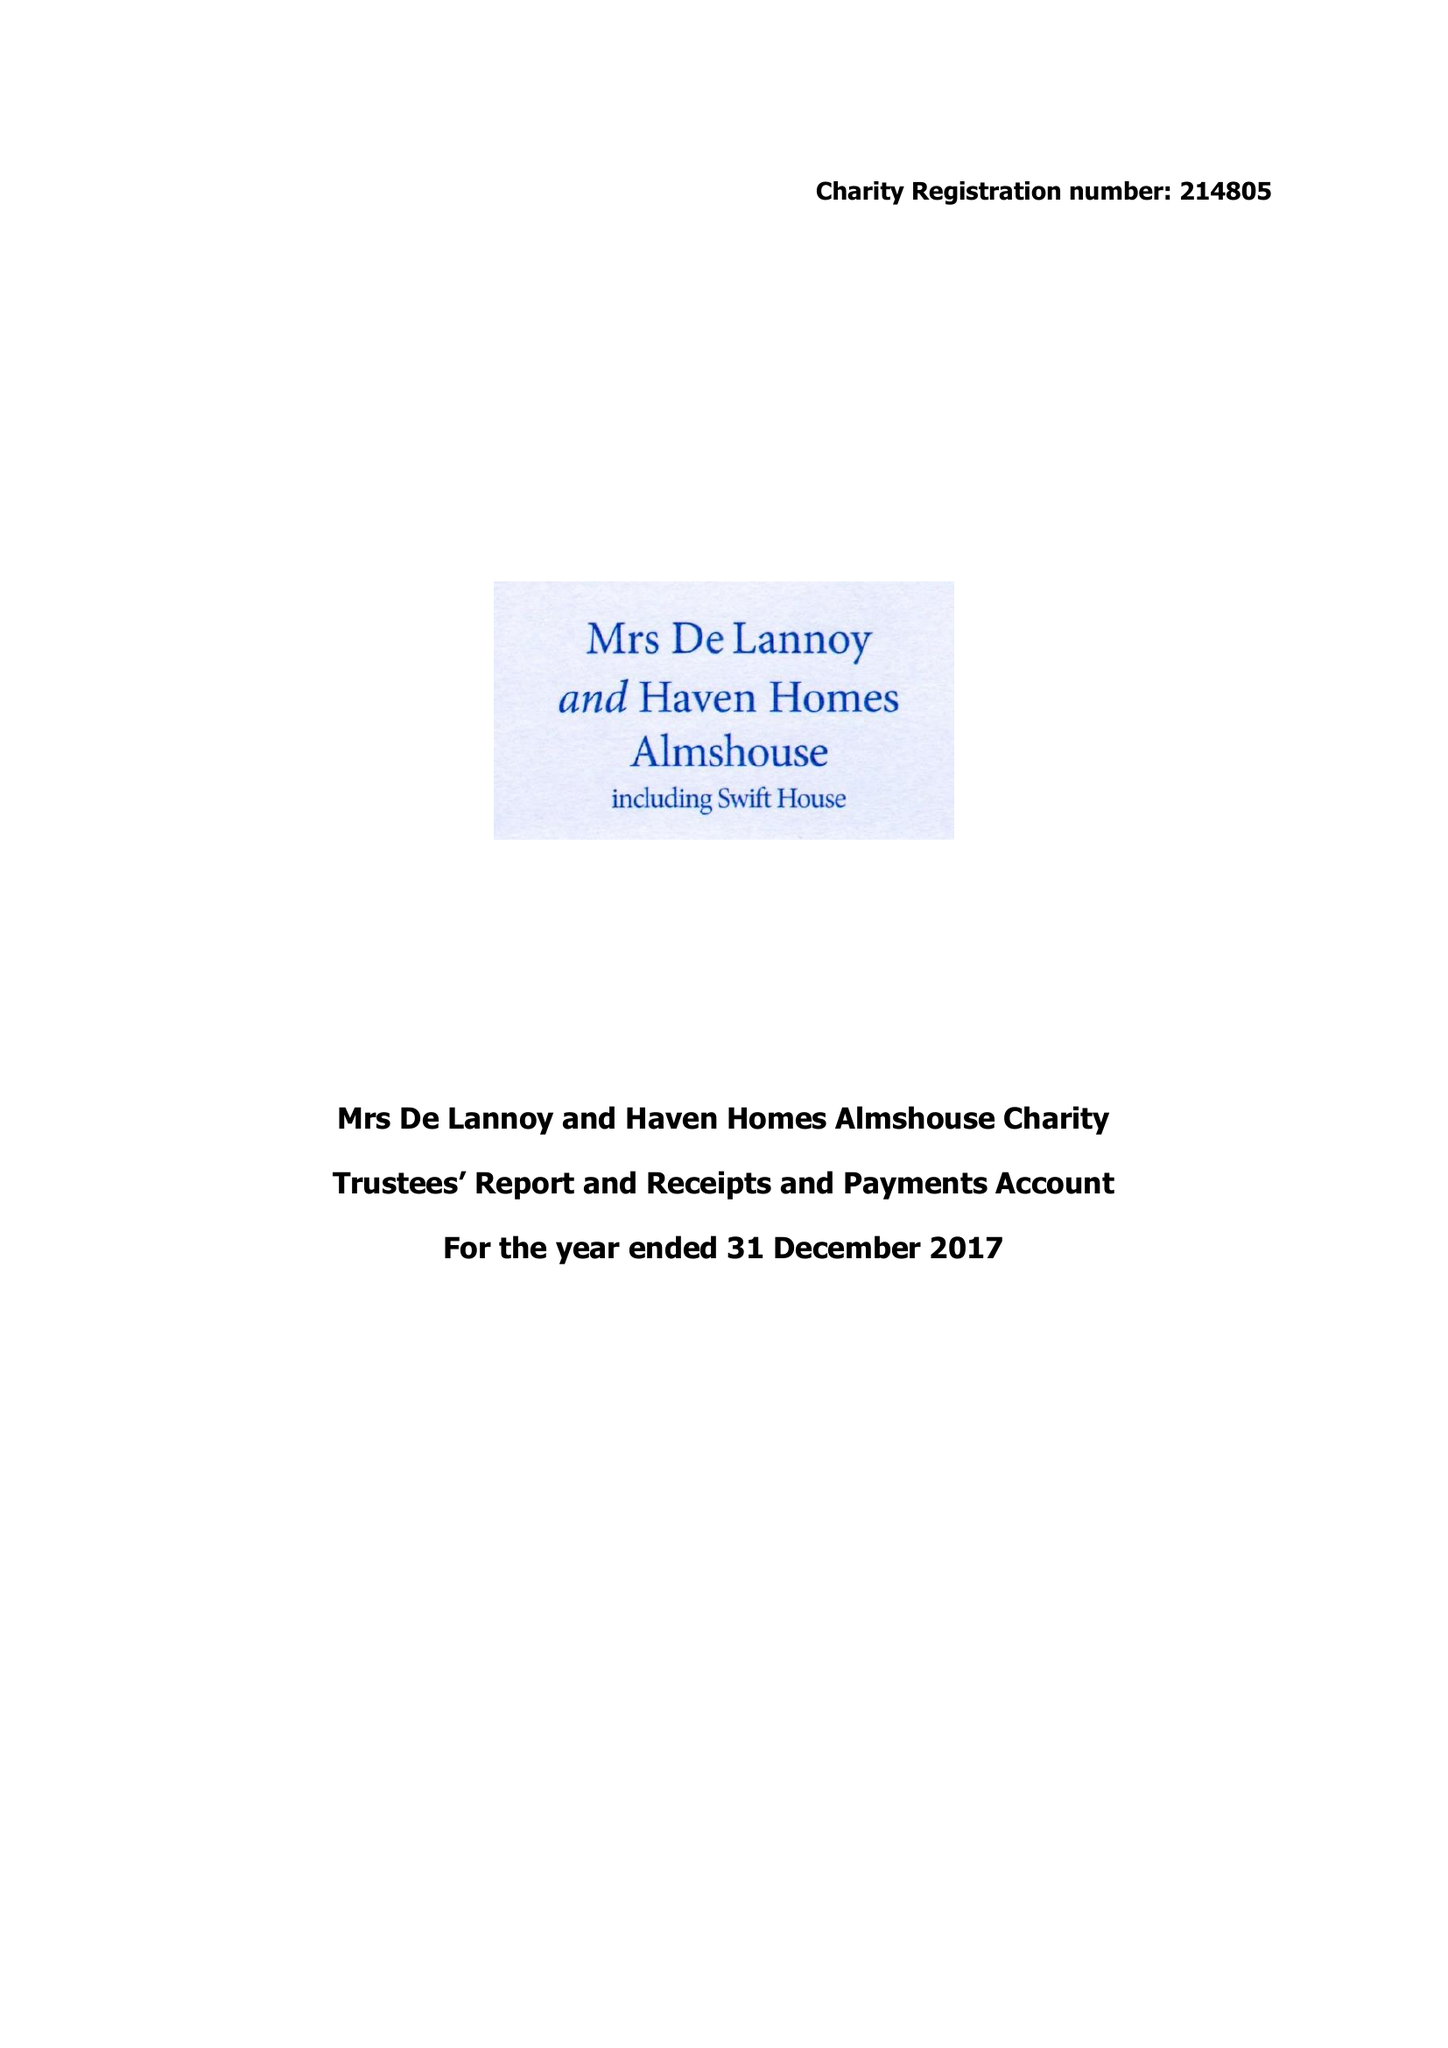What is the value for the address__street_line?
Answer the question using a single word or phrase. None 